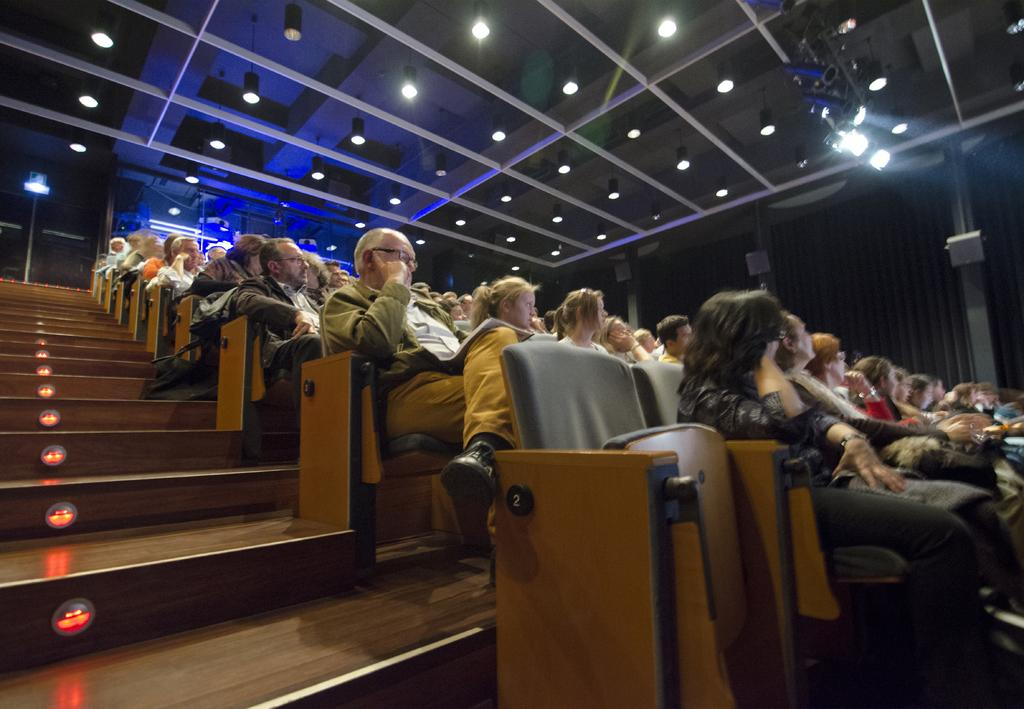What are the people in the image doing? There is a group of people sitting on chairs in the image. What can be seen on the left side of the image? There are steps, lights, and a door on the left side of the image. What is present on the right side of the image? There are lights on the ceiling and a wall on the right side of the image. What type of pickle is being used as a decoration on the wall in the image? There is no pickle present in the image; it is a wall with lights on the right side. 